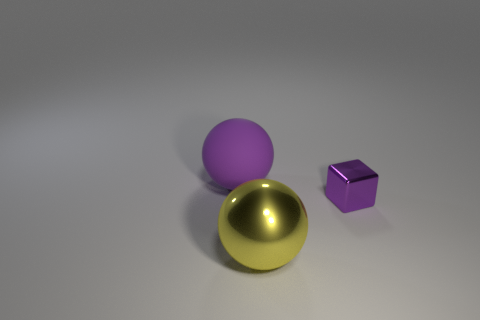Is the size of the purple rubber sphere the same as the purple object that is right of the purple matte thing?
Provide a succinct answer. No. The thing that is behind the yellow shiny object and left of the small purple metallic cube is what color?
Offer a very short reply. Purple. The rubber thing has what size?
Provide a succinct answer. Large. There is a large object behind the small purple object; is it the same color as the small shiny thing?
Offer a very short reply. Yes. Are there more things that are left of the cube than big shiny spheres behind the large shiny sphere?
Make the answer very short. Yes. Is the number of purple metal objects greater than the number of tiny brown shiny objects?
Provide a short and direct response. Yes. There is a object that is on the left side of the small purple metallic object and on the right side of the big matte thing; how big is it?
Provide a short and direct response. Large. What shape is the yellow thing?
Provide a succinct answer. Sphere. Is there anything else that has the same size as the purple metallic block?
Your answer should be compact. No. Are there more big yellow spheres that are behind the small purple block than spheres?
Give a very brief answer. No. 